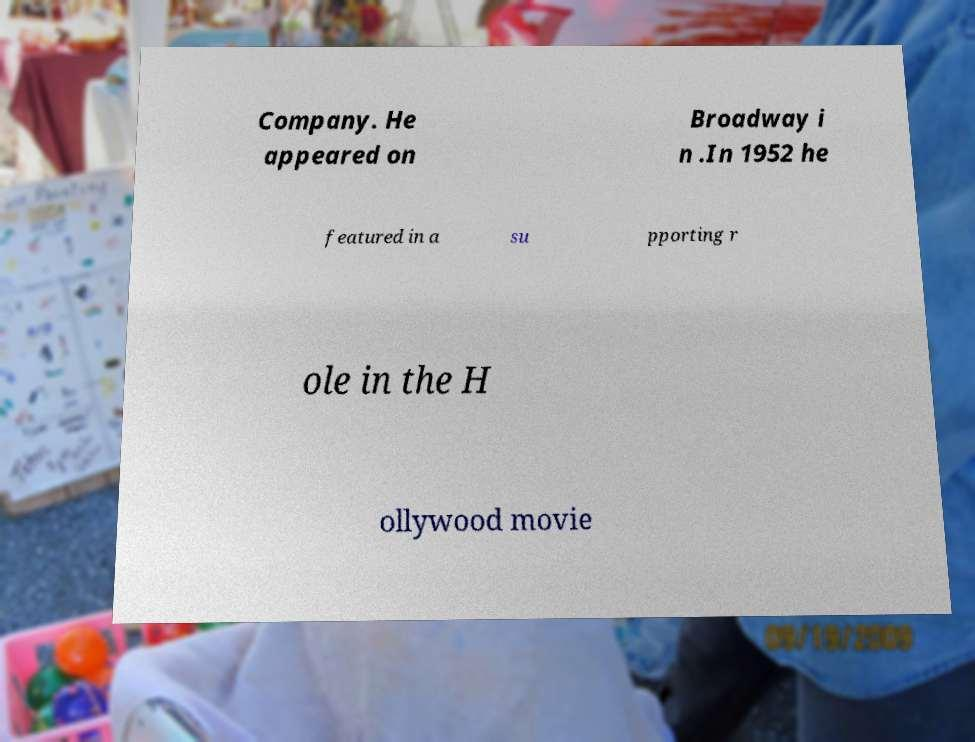Please read and relay the text visible in this image. What does it say? Company. He appeared on Broadway i n .In 1952 he featured in a su pporting r ole in the H ollywood movie 